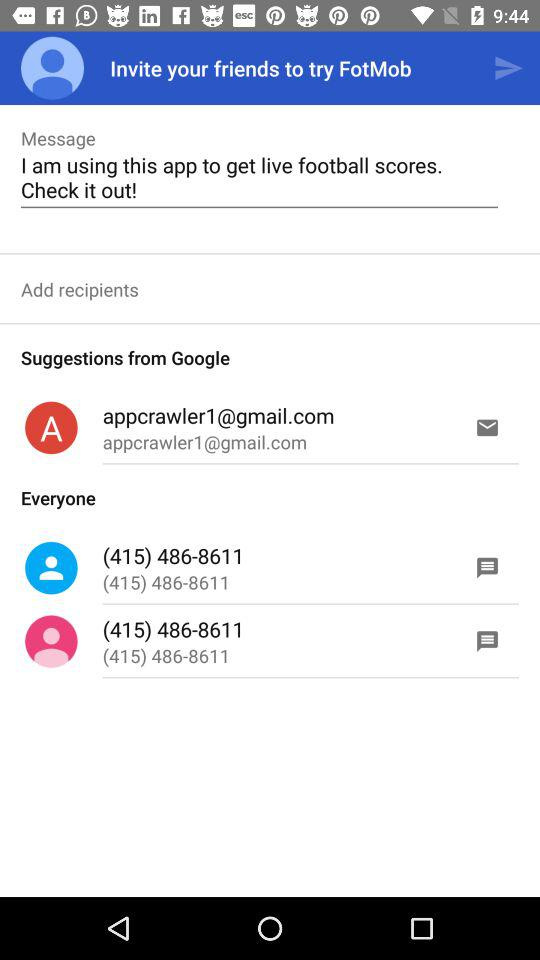What is the name of the application? The name of the application is "FotMob". 